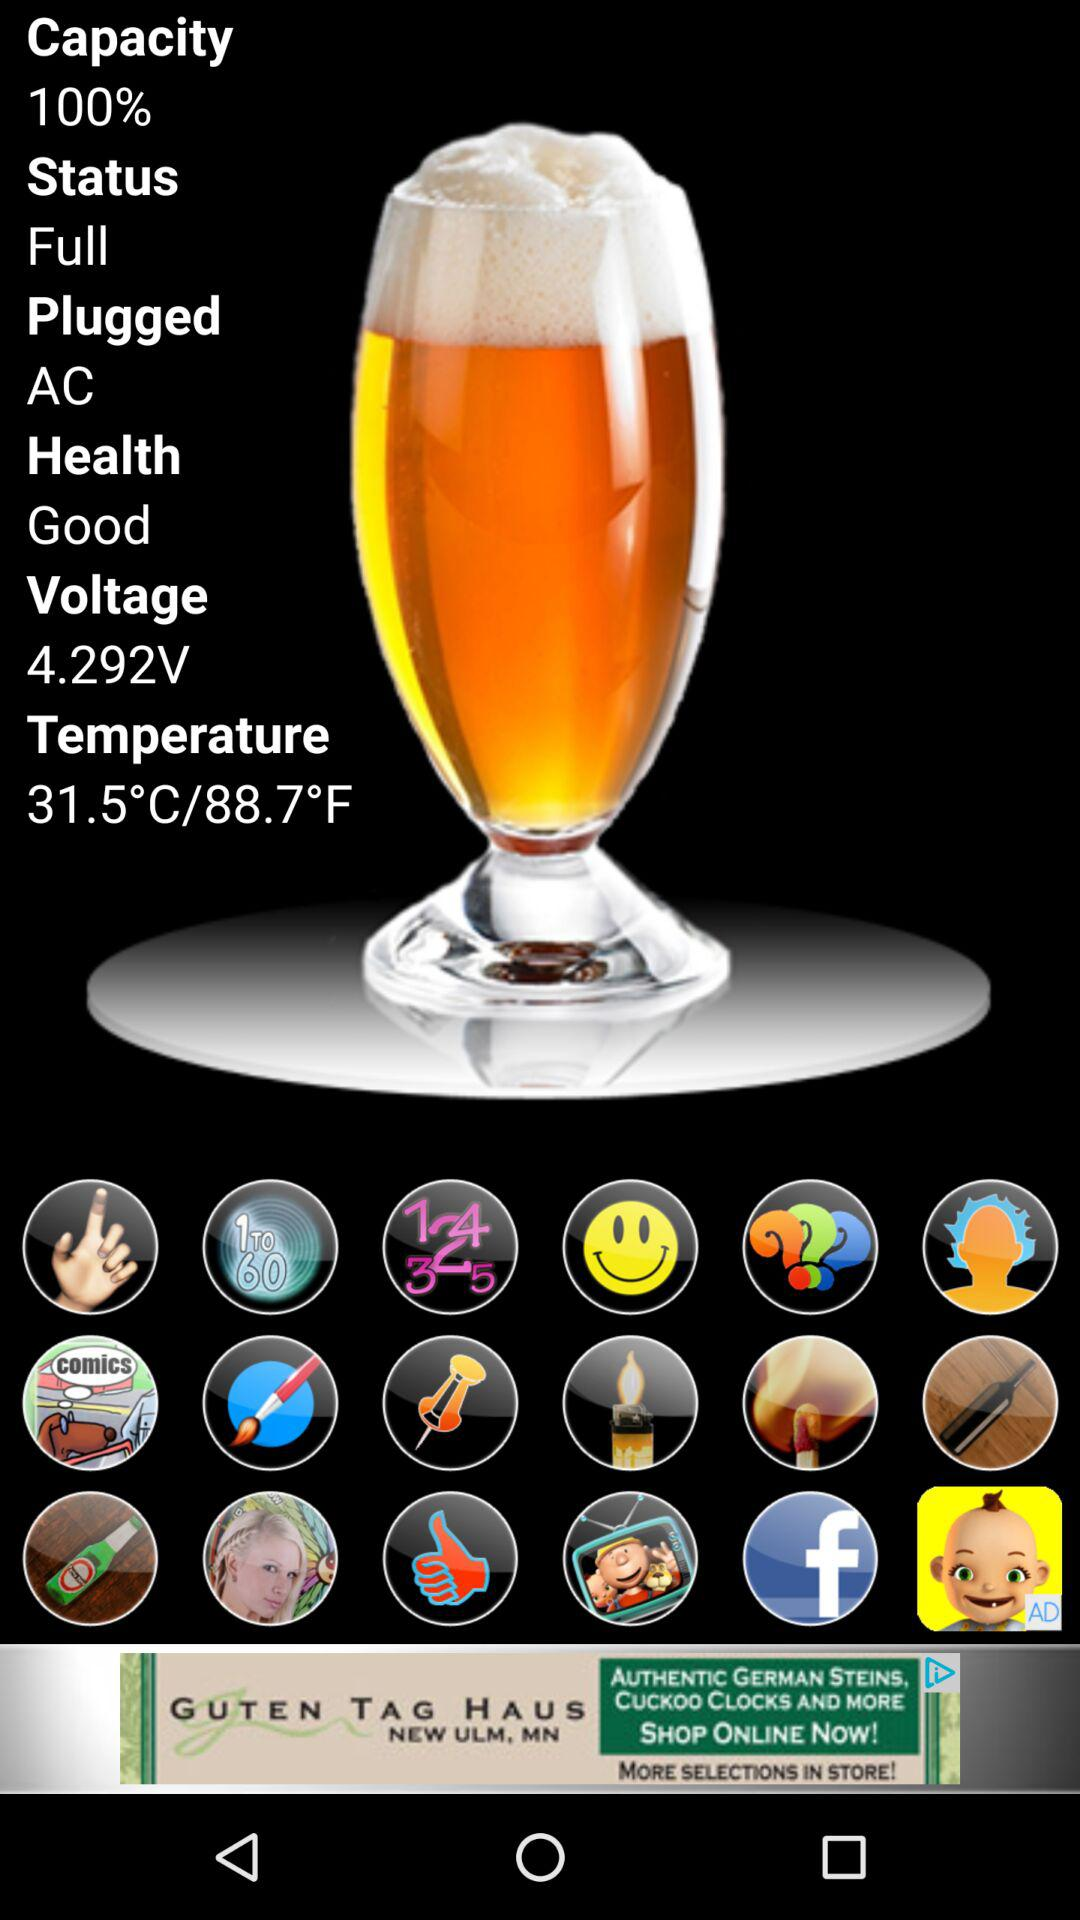What is the status? The status is "Full". 